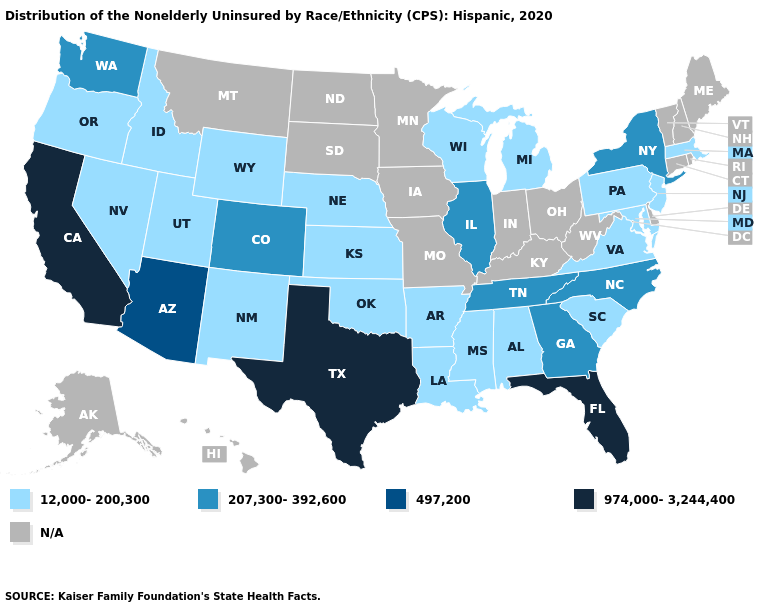Name the states that have a value in the range 12,000-200,300?
Keep it brief. Alabama, Arkansas, Idaho, Kansas, Louisiana, Maryland, Massachusetts, Michigan, Mississippi, Nebraska, Nevada, New Jersey, New Mexico, Oklahoma, Oregon, Pennsylvania, South Carolina, Utah, Virginia, Wisconsin, Wyoming. Name the states that have a value in the range 207,300-392,600?
Concise answer only. Colorado, Georgia, Illinois, New York, North Carolina, Tennessee, Washington. How many symbols are there in the legend?
Write a very short answer. 5. What is the value of Vermont?
Keep it brief. N/A. What is the lowest value in states that border Rhode Island?
Short answer required. 12,000-200,300. Does the map have missing data?
Keep it brief. Yes. Name the states that have a value in the range 974,000-3,244,400?
Quick response, please. California, Florida, Texas. Name the states that have a value in the range 12,000-200,300?
Write a very short answer. Alabama, Arkansas, Idaho, Kansas, Louisiana, Maryland, Massachusetts, Michigan, Mississippi, Nebraska, Nevada, New Jersey, New Mexico, Oklahoma, Oregon, Pennsylvania, South Carolina, Utah, Virginia, Wisconsin, Wyoming. Does Texas have the lowest value in the South?
Short answer required. No. Which states have the lowest value in the USA?
Be succinct. Alabama, Arkansas, Idaho, Kansas, Louisiana, Maryland, Massachusetts, Michigan, Mississippi, Nebraska, Nevada, New Jersey, New Mexico, Oklahoma, Oregon, Pennsylvania, South Carolina, Utah, Virginia, Wisconsin, Wyoming. How many symbols are there in the legend?
Answer briefly. 5. Name the states that have a value in the range 974,000-3,244,400?
Answer briefly. California, Florida, Texas. Among the states that border Alabama , which have the lowest value?
Give a very brief answer. Mississippi. 